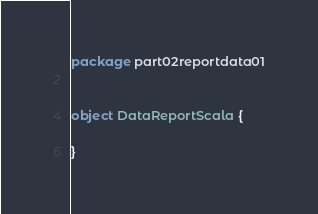<code> <loc_0><loc_0><loc_500><loc_500><_Scala_>package part02reportdata01


object DataReportScala {

}
</code> 